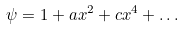Convert formula to latex. <formula><loc_0><loc_0><loc_500><loc_500>\psi = 1 + a x ^ { 2 } + c x ^ { 4 } + \dots</formula> 